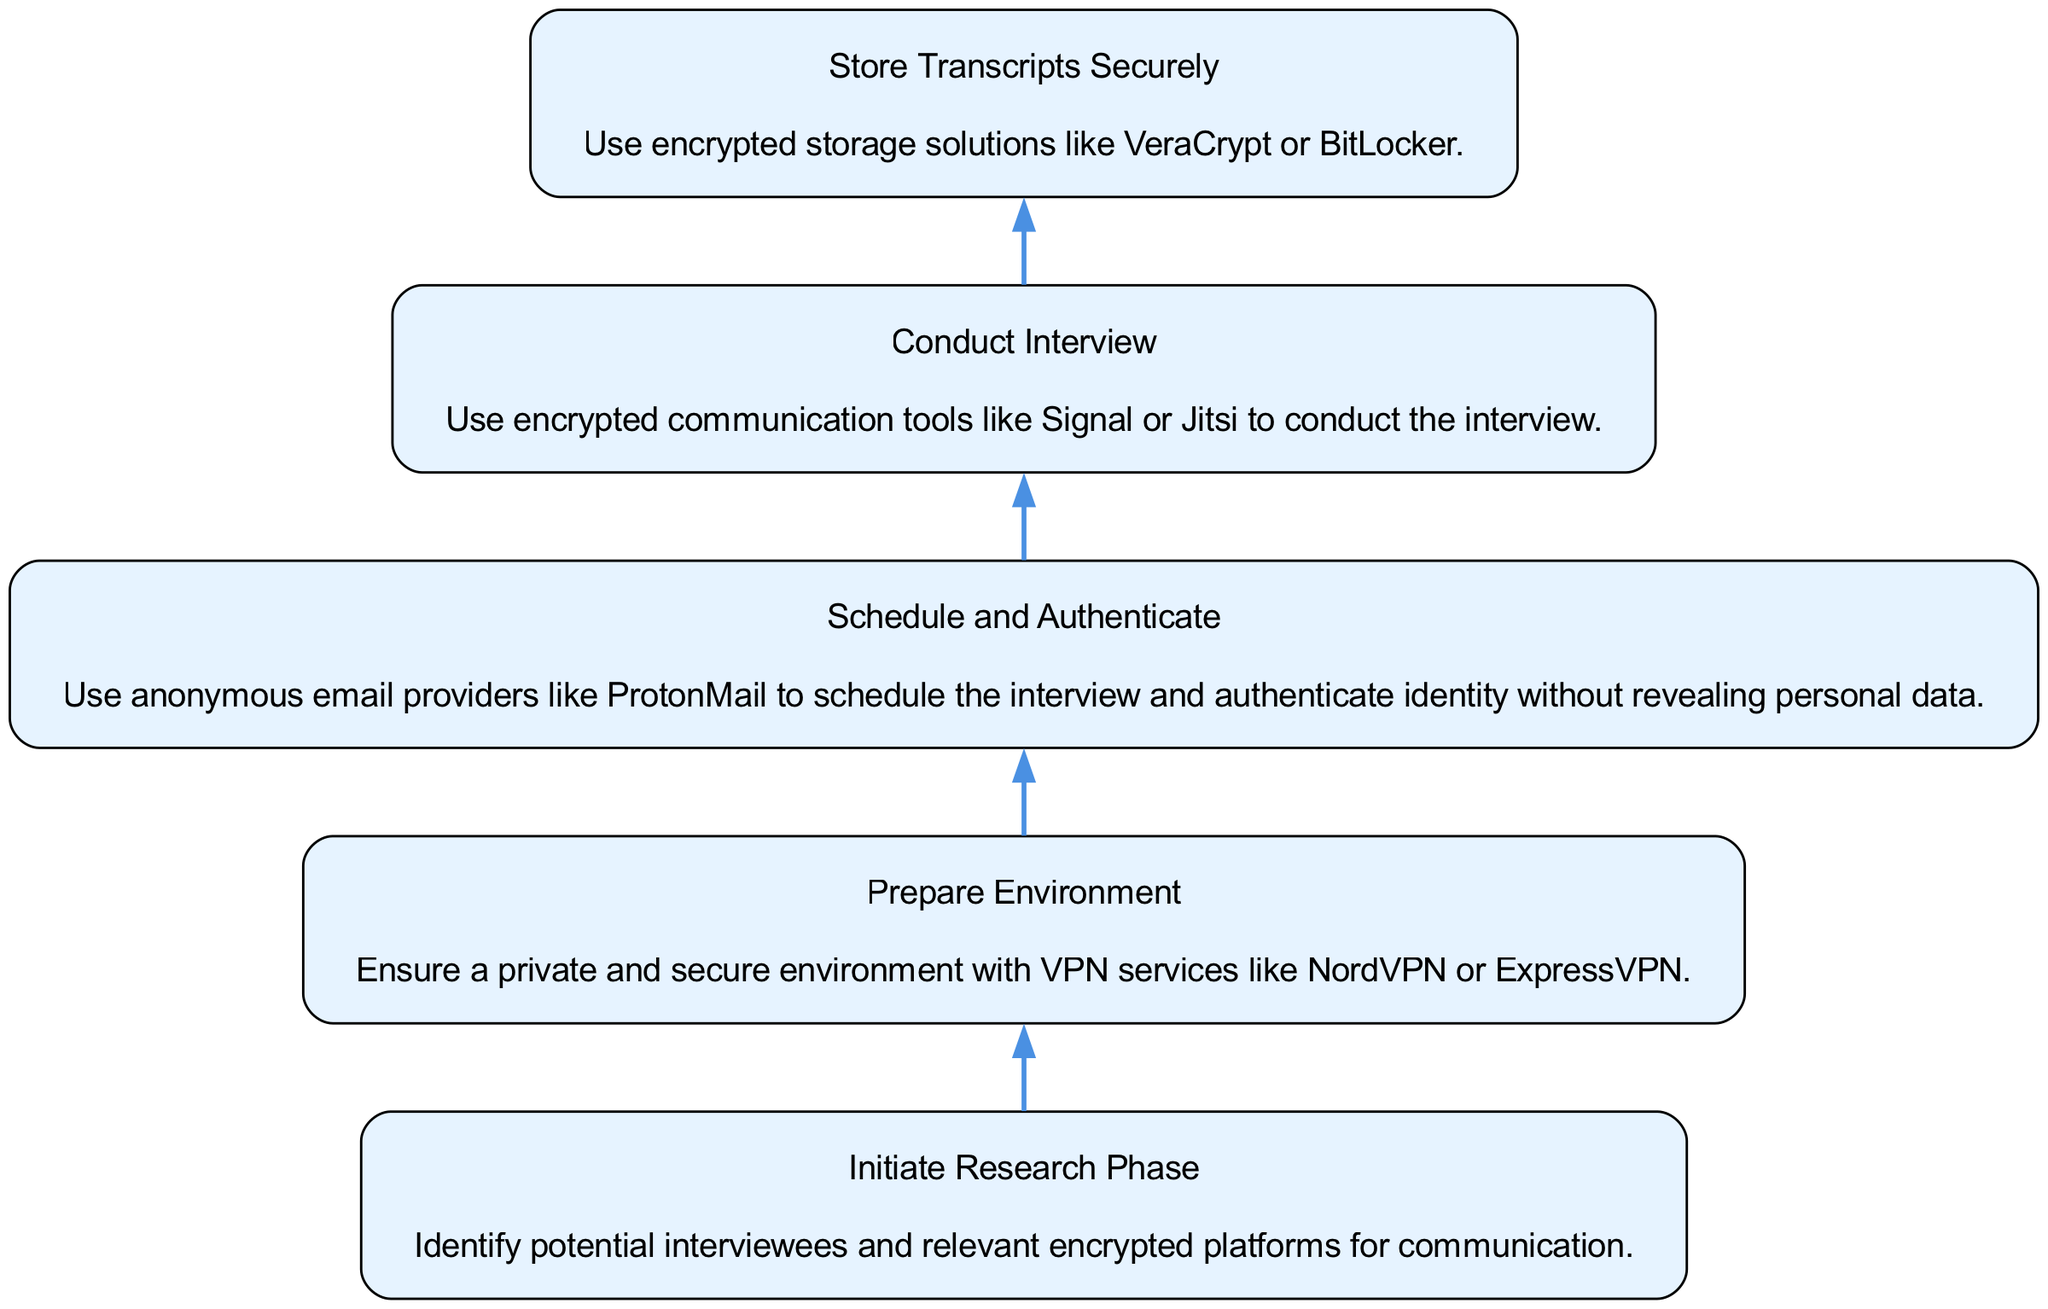what is the last step in the flow? The flow chart lists the steps in a sequence, with "Store Transcripts Securely" being the final step since it does not have a following step indicated.
Answer: Store Transcripts Securely how many steps are in the process? The diagram contains five specific steps from "Initiate Research Phase" to "Store Transcripts Securely." Each step is denoted as a distinct element in the flow from bottom to top.
Answer: 5 what is the description of the second step? The second step, "Schedule and Authenticate," involves using anonymous email providers for scheduling and authentication that protect personal data. This information is extracted directly from the node's description.
Answer: Use anonymous email providers like ProtonMail to schedule the interview and authenticate identity without revealing personal data which step follows "Conduct Interview"? According to the flow, the step that follows "Conduct Interview" is "Store Transcripts Securely," as shown by the directed edge leading from "Conduct Interview" to "Store Transcripts Securely."
Answer: Store Transcripts Securely what is the starting point of the flow? The starting point in the flow chart is labeled "Initiate Research Phase," which signifies the initial action before any subsequent steps are taken. This information is found at the bottom of the diagram.
Answer: Initiate Research Phase how does "Prepare Environment" relate to the following steps? "Prepare Environment" is the first step in the process and leads to "Schedule and Authenticate," establishing a dependency in which the environment must be prepared before any scheduling or authentication can occur. This shows a directional flow from one step to the next.
Answer: It is the first step leading to further steps 